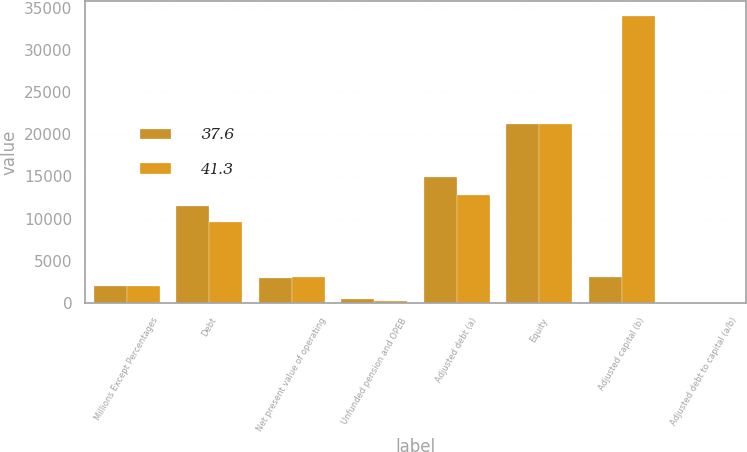<chart> <loc_0><loc_0><loc_500><loc_500><stacked_bar_chart><ecel><fcel>Millions Except Percentages<fcel>Debt<fcel>Net present value of operating<fcel>Unfunded pension and OPEB<fcel>Adjusted debt (a)<fcel>Equity<fcel>Adjusted capital (b)<fcel>Adjusted debt to capital (a/b)<nl><fcel>37.6<fcel>2014<fcel>11480<fcel>2902<fcel>523<fcel>14905<fcel>21189<fcel>3057<fcel>41.3<nl><fcel>41.3<fcel>2013<fcel>9577<fcel>3057<fcel>170<fcel>12804<fcel>21225<fcel>34029<fcel>37.6<nl></chart> 